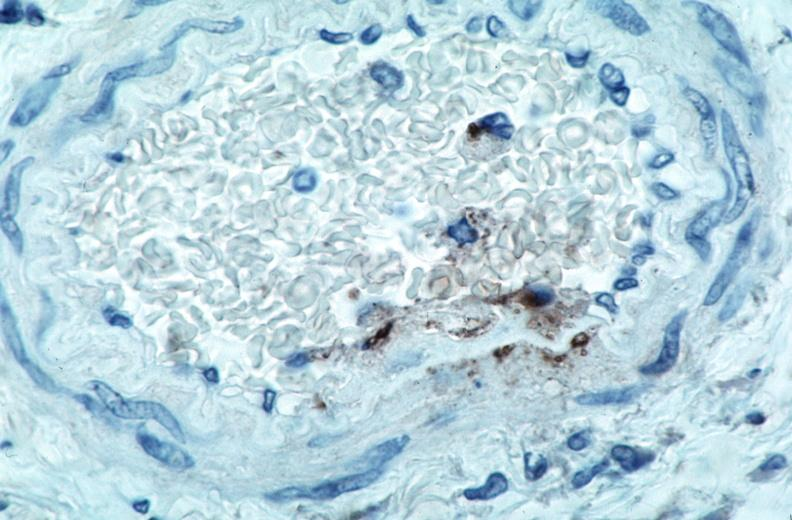what spotted fever , immunoperoxidase staining vessels for rickettsia rickettsii?
Answer the question using a single word or phrase. Vasculitis rocky mountain 